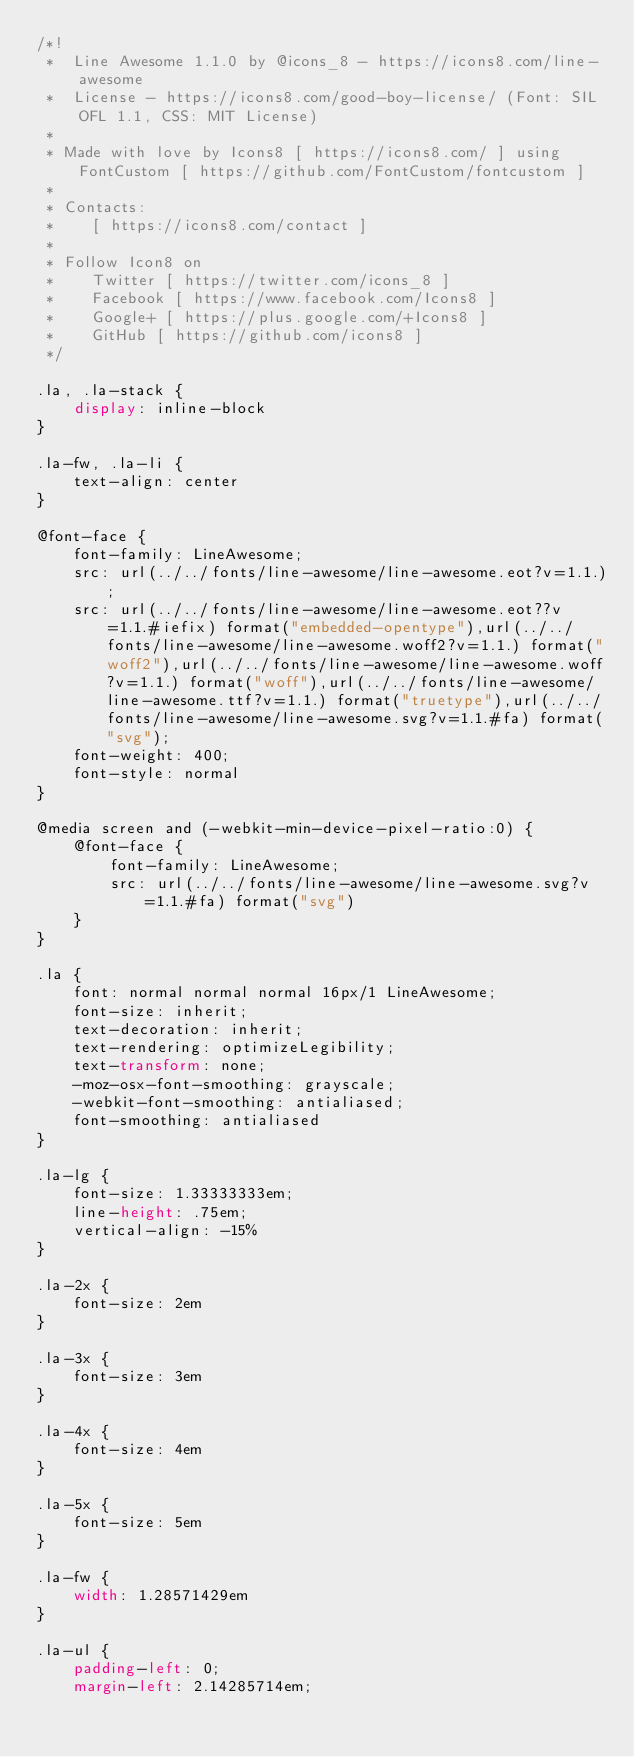Convert code to text. <code><loc_0><loc_0><loc_500><loc_500><_CSS_>/*!
 *  Line Awesome 1.1.0 by @icons_8 - https://icons8.com/line-awesome
 *  License - https://icons8.com/good-boy-license/ (Font: SIL OFL 1.1, CSS: MIT License)
 *
 * Made with love by Icons8 [ https://icons8.com/ ] using FontCustom [ https://github.com/FontCustom/fontcustom ]
 *
 * Contacts:
 *    [ https://icons8.com/contact ]
 *
 * Follow Icon8 on
 *    Twitter [ https://twitter.com/icons_8 ]
 *    Facebook [ https://www.facebook.com/Icons8 ]
 *    Google+ [ https://plus.google.com/+Icons8 ]
 *    GitHub [ https://github.com/icons8 ]
 */

.la, .la-stack {
    display: inline-block
}

.la-fw, .la-li {
    text-align: center
}

@font-face {
    font-family: LineAwesome;
    src: url(../../fonts/line-awesome/line-awesome.eot?v=1.1.);
    src: url(../../fonts/line-awesome/line-awesome.eot??v=1.1.#iefix) format("embedded-opentype"),url(../../fonts/line-awesome/line-awesome.woff2?v=1.1.) format("woff2"),url(../../fonts/line-awesome/line-awesome.woff?v=1.1.) format("woff"),url(../../fonts/line-awesome/line-awesome.ttf?v=1.1.) format("truetype"),url(../../fonts/line-awesome/line-awesome.svg?v=1.1.#fa) format("svg");
    font-weight: 400;
    font-style: normal
}

@media screen and (-webkit-min-device-pixel-ratio:0) {
    @font-face {
        font-family: LineAwesome;
        src: url(../../fonts/line-awesome/line-awesome.svg?v=1.1.#fa) format("svg")
    }
}

.la {
    font: normal normal normal 16px/1 LineAwesome;
    font-size: inherit;
    text-decoration: inherit;
    text-rendering: optimizeLegibility;
    text-transform: none;
    -moz-osx-font-smoothing: grayscale;
    -webkit-font-smoothing: antialiased;
    font-smoothing: antialiased
}

.la-lg {
    font-size: 1.33333333em;
    line-height: .75em;
    vertical-align: -15%
}

.la-2x {
    font-size: 2em
}

.la-3x {
    font-size: 3em
}

.la-4x {
    font-size: 4em
}

.la-5x {
    font-size: 5em
}

.la-fw {
    width: 1.28571429em
}

.la-ul {
    padding-left: 0;
    margin-left: 2.14285714em;</code> 